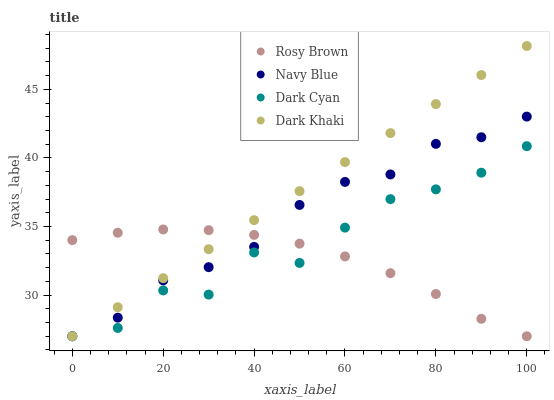Does Rosy Brown have the minimum area under the curve?
Answer yes or no. Yes. Does Dark Khaki have the maximum area under the curve?
Answer yes or no. Yes. Does Navy Blue have the minimum area under the curve?
Answer yes or no. No. Does Navy Blue have the maximum area under the curve?
Answer yes or no. No. Is Dark Khaki the smoothest?
Answer yes or no. Yes. Is Dark Cyan the roughest?
Answer yes or no. Yes. Is Navy Blue the smoothest?
Answer yes or no. No. Is Navy Blue the roughest?
Answer yes or no. No. Does Dark Cyan have the lowest value?
Answer yes or no. Yes. Does Dark Khaki have the highest value?
Answer yes or no. Yes. Does Navy Blue have the highest value?
Answer yes or no. No. Does Dark Khaki intersect Rosy Brown?
Answer yes or no. Yes. Is Dark Khaki less than Rosy Brown?
Answer yes or no. No. Is Dark Khaki greater than Rosy Brown?
Answer yes or no. No. 